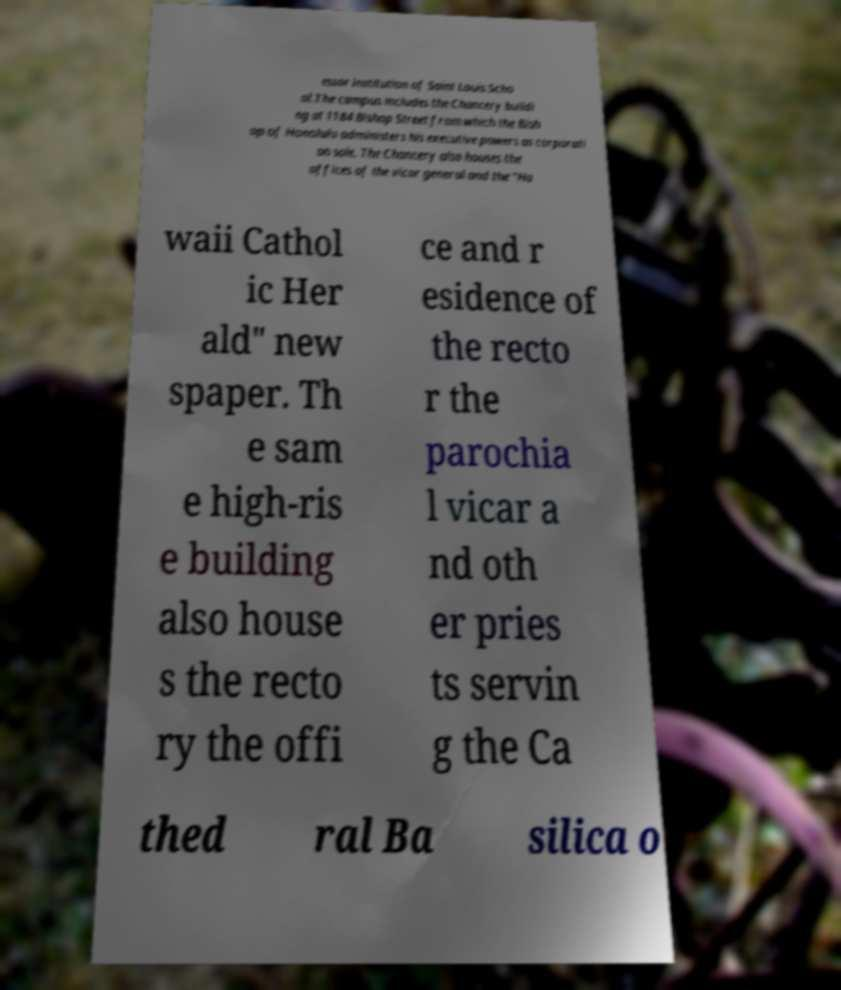I need the written content from this picture converted into text. Can you do that? essor institution of Saint Louis Scho ol.The campus includes the Chancery buildi ng at 1184 Bishop Street from which the Bish op of Honolulu administers his executive powers as corporati on sole. The Chancery also houses the offices of the vicar general and the "Ha waii Cathol ic Her ald" new spaper. Th e sam e high-ris e building also house s the recto ry the offi ce and r esidence of the recto r the parochia l vicar a nd oth er pries ts servin g the Ca thed ral Ba silica o 